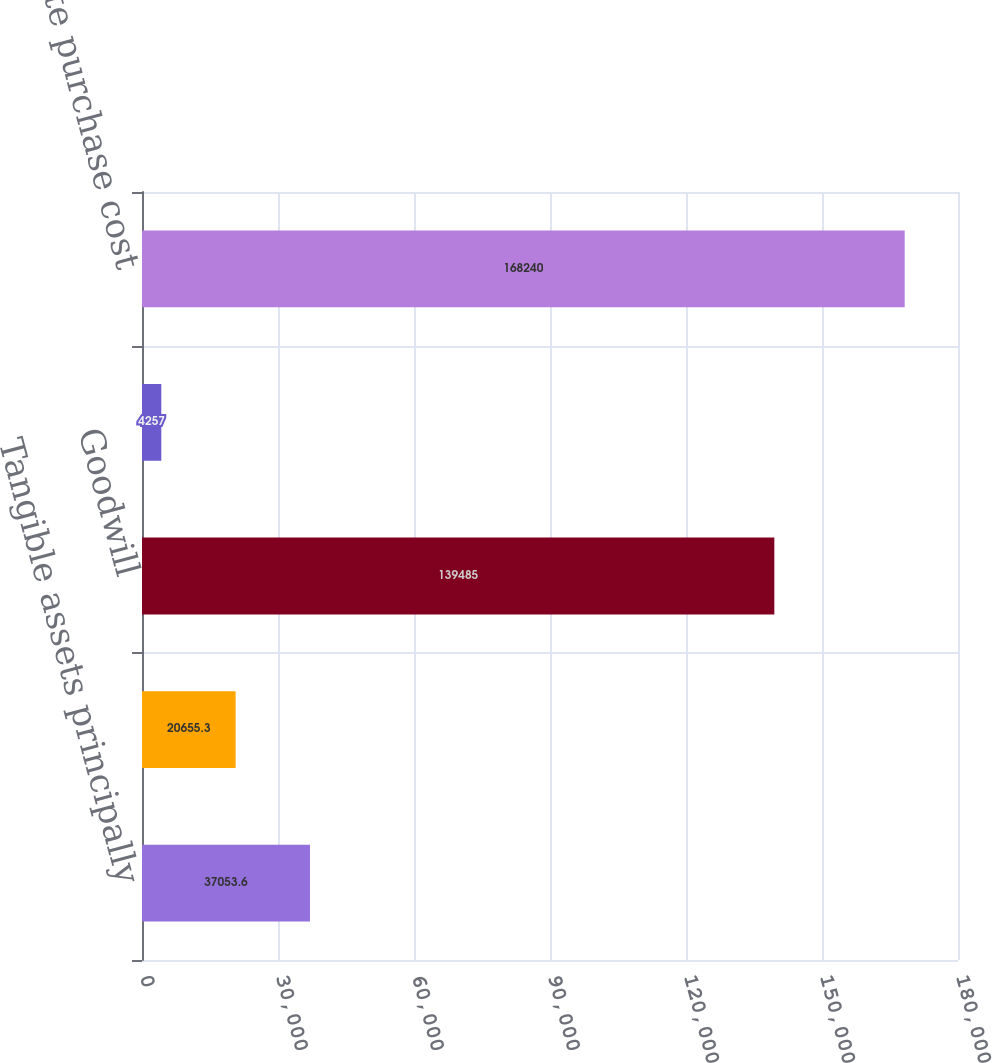Convert chart to OTSL. <chart><loc_0><loc_0><loc_500><loc_500><bar_chart><fcel>Tangible assets principally<fcel>Amortizable intangible assets<fcel>Goodwill<fcel>Liabilities assumed<fcel>Aggregate purchase cost<nl><fcel>37053.6<fcel>20655.3<fcel>139485<fcel>4257<fcel>168240<nl></chart> 